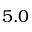Convert formula to latex. <formula><loc_0><loc_0><loc_500><loc_500>5 . 0</formula> 